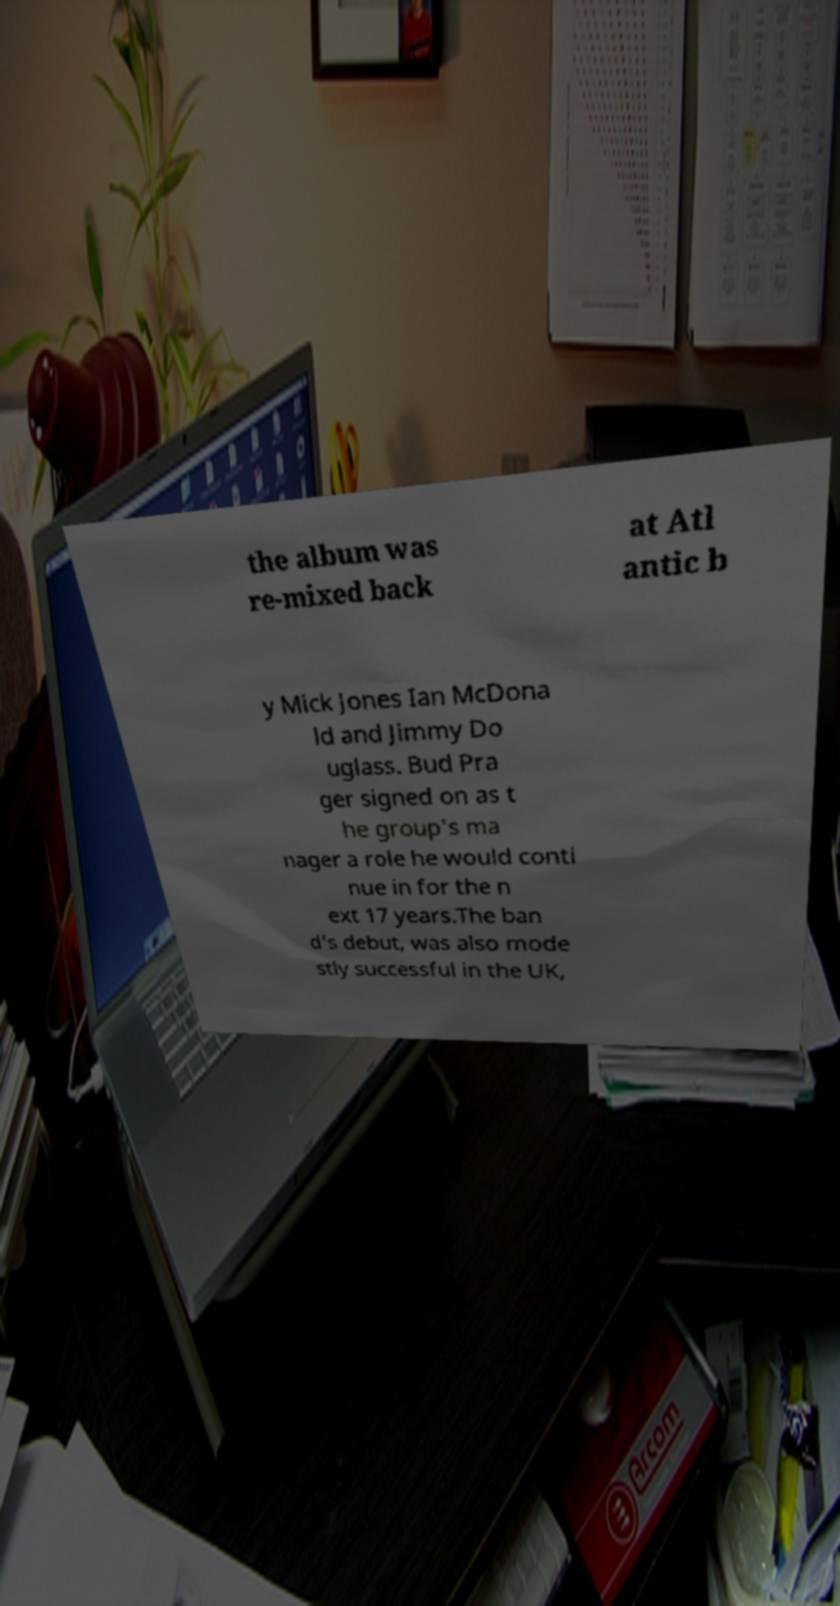Please read and relay the text visible in this image. What does it say? the album was re-mixed back at Atl antic b y Mick Jones Ian McDona ld and Jimmy Do uglass. Bud Pra ger signed on as t he group's ma nager a role he would conti nue in for the n ext 17 years.The ban d's debut, was also mode stly successful in the UK, 